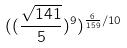<formula> <loc_0><loc_0><loc_500><loc_500>( ( \frac { \sqrt { 1 4 1 } } { 5 } ) ^ { 9 } ) ^ { \frac { 6 } { 1 5 9 } / 1 0 }</formula> 